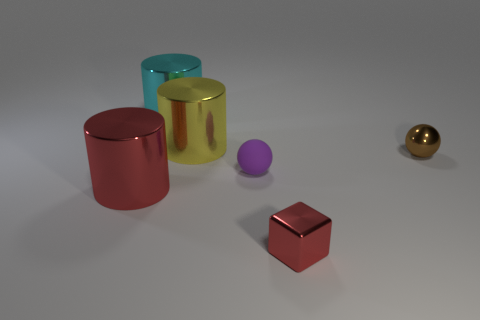Are any big cyan rubber blocks visible?
Provide a succinct answer. No. Is there anything else that has the same shape as the tiny red metal thing?
Offer a terse response. No. Are there more big cyan metallic things to the left of the small red block than large red cubes?
Make the answer very short. Yes. Are there any big yellow cylinders behind the small rubber sphere?
Your answer should be compact. Yes. Is the size of the yellow thing the same as the cube?
Offer a terse response. No. What is the size of the other object that is the same shape as the small purple object?
Provide a short and direct response. Small. Is there any other thing that has the same size as the cyan cylinder?
Keep it short and to the point. Yes. What material is the large object to the right of the big cyan metal thing right of the large red shiny cylinder made of?
Provide a succinct answer. Metal. Does the large red metallic object have the same shape as the big yellow object?
Provide a short and direct response. Yes. How many things are both right of the cyan metal object and behind the big red shiny object?
Your answer should be compact. 3. 